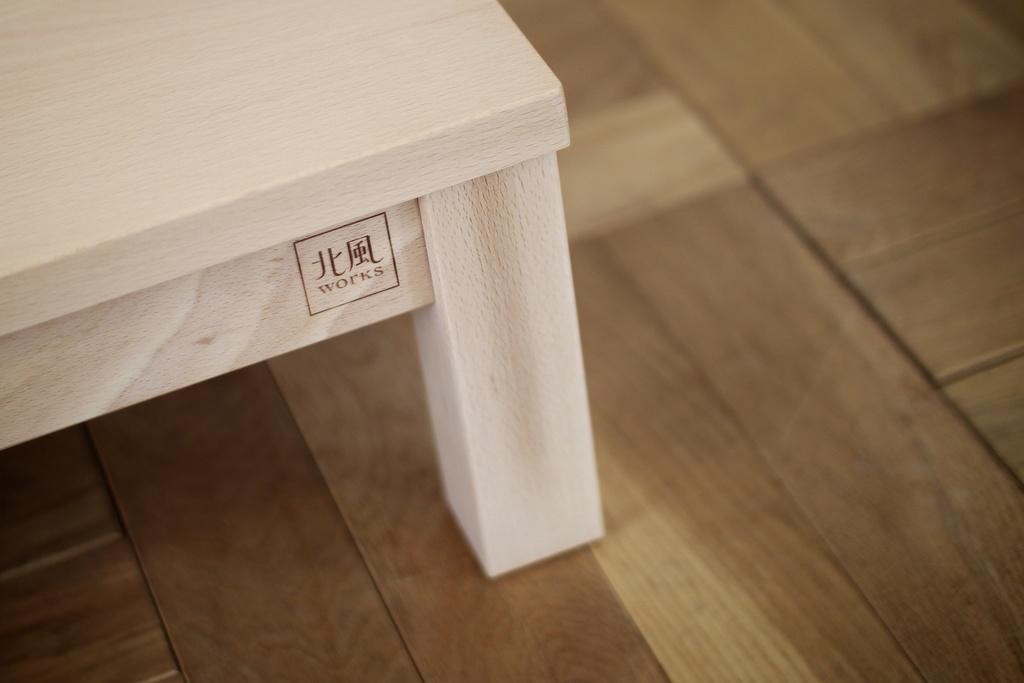What is the color of the object in the image? The object in the image is white-colored. What is written or printed on the object? The object has text on it. On what type of surface is the object placed? The object is on a wooden surface. What type of winter clothing is the man wearing in the image? There is no man present in the image, and therefore no winter clothing can be observed. 